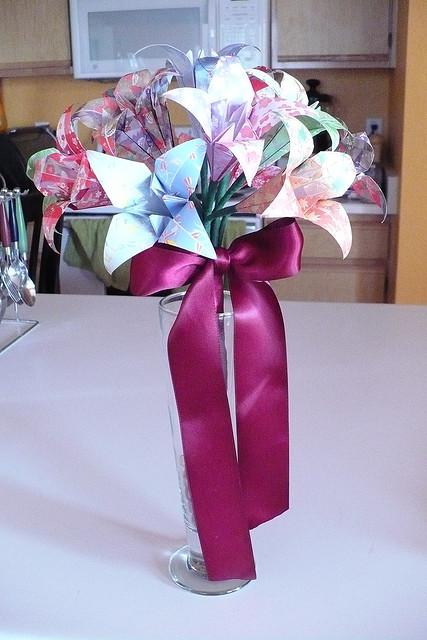What do you think these flowers symbolize?
Be succinct. Easter. Is it difficult to see the vase the flowers are in?
Write a very short answer. Yes. What kind of flowers are these?
Answer briefly. Tulips. 